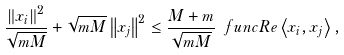<formula> <loc_0><loc_0><loc_500><loc_500>\frac { \left \| x _ { i } \right \| ^ { 2 } } { \sqrt { m M } } + \sqrt { m M } \left \| x _ { j } \right \| ^ { 2 } \leq \frac { M + m } { \sqrt { m M } } \ f u n c { R e } \left \langle x _ { i } , x _ { j } \right \rangle ,</formula> 